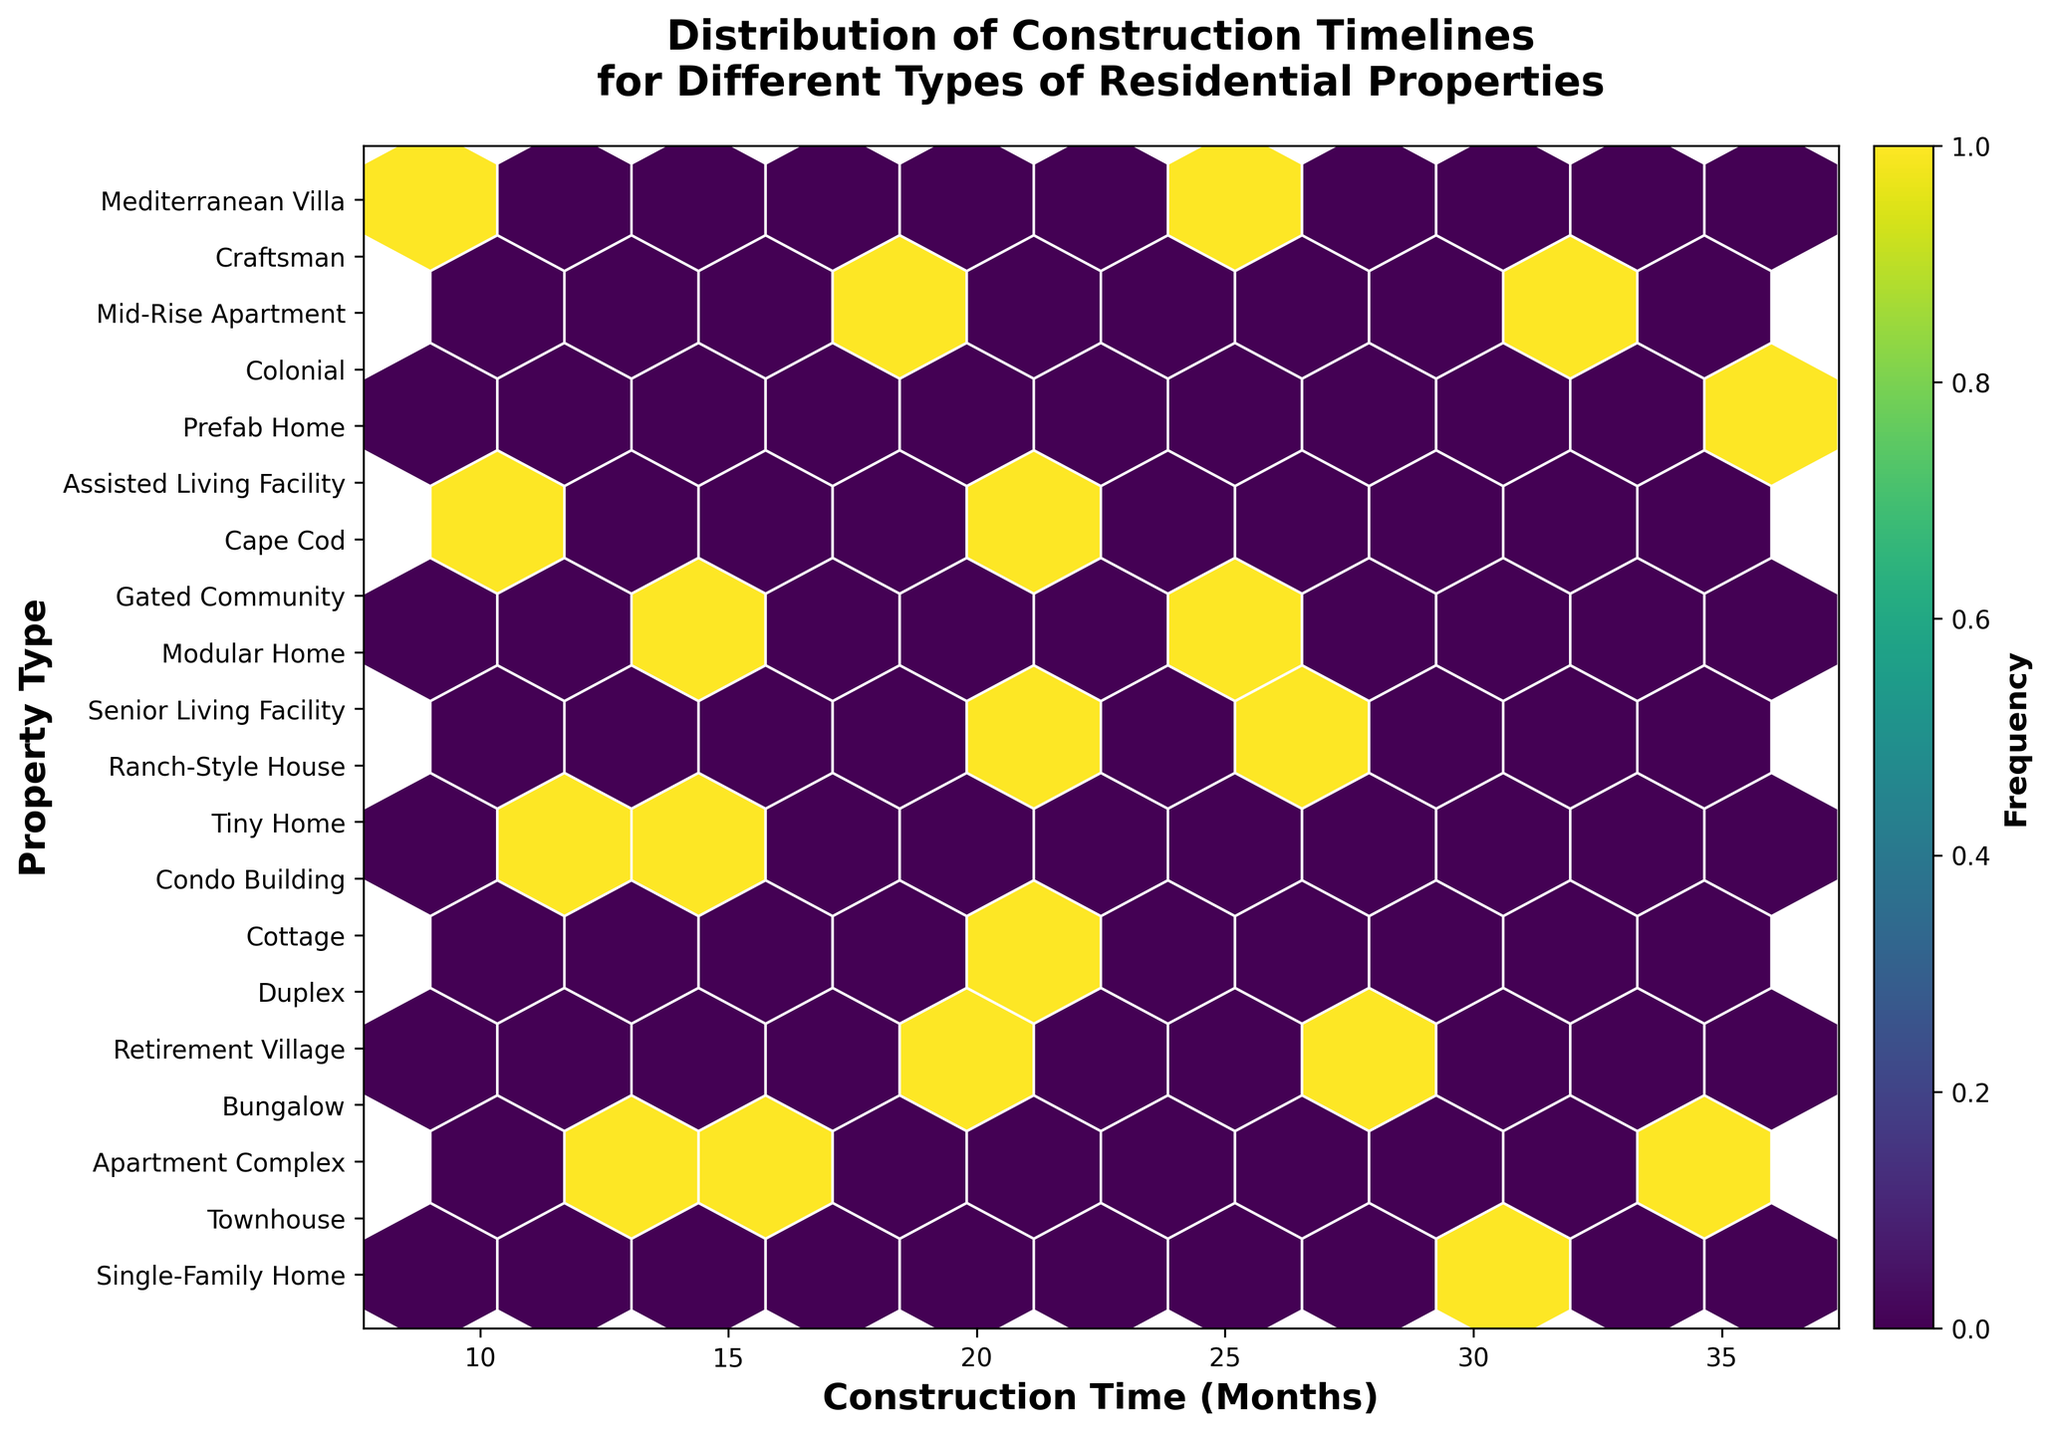What is the title of the plot? The title of the plot is displayed at the top and reads "Distribution of Construction Timelines for Different Types of Residential Properties."
Answer: Distribution of Construction Timelines for Different Types of Residential Properties Which property type has the shortest construction time? By looking at the y-axis and finding the lowest corresponding x-axis value, the shortest construction time, which is 9 months, corresponds to the "Tiny Home."
Answer: Tiny Home How is the color used to represent the frequency of data points? The color map, displayed on the right side of the plot, uses various shades from light to dark where darker colors indicate a higher frequency of data points.
Answer: Darker colors indicate higher frequency Which property type generally takes around 20 months to complete? From the x-axis, find the value around 20 months, then trace vertically to see which property types align closely with that time on the y-axis. "Cottage" and "Mediterranean Villa" are close to 20 months.
Answer: Cottage, Mediterranean Villa What does a higher density of hexagons indicate? A higher density of hexagons, especially those with darker colors, indicates that more data points (construction timelines) fall within that range for various property types.
Answer: More data points fall within that range Are there any property types that have construction times greater than 30 months? By examining the x-axis values greater than 30 months, the corresponding property types on the y-axis are "Retirement Village," "Senior Living Facility," and "Assisted Living Facility."
Answer: Retirement Village, Senior Living Facility, Assisted Living Facility How many property types are shown in the plot? Counting the unique labels on the y-axis, there are 20 different property types shown in the plot.
Answer: 20 What range of construction times is covered in the plot? The x-axis ranges from the shortest time of 9 months to the longest time of 36 months, covering the entire construction timeline range.
Answer: 9 to 36 months Which property type has a construction time closest to 28 months? By locating 28 months on the x-axis and finding the y-axis label directly corresponding to it, "Condo Building" is closely aligned with 28 months.
Answer: Condo Building 